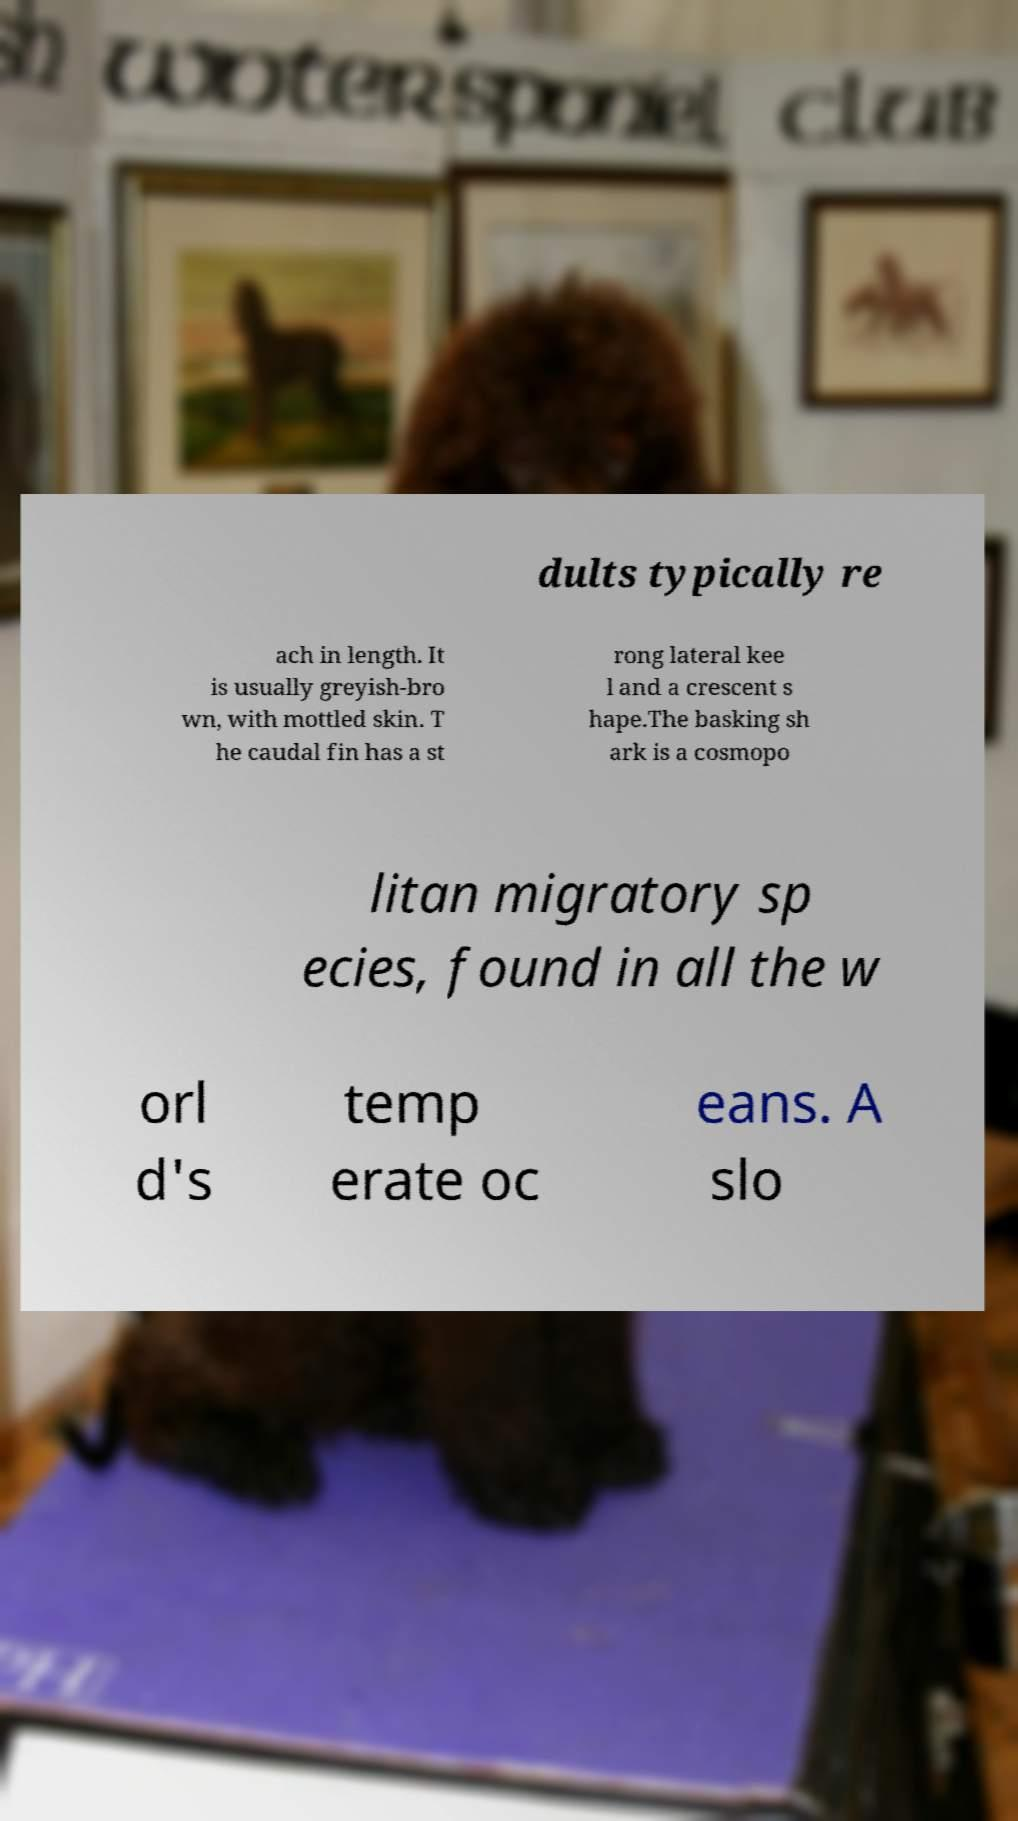Can you accurately transcribe the text from the provided image for me? dults typically re ach in length. It is usually greyish-bro wn, with mottled skin. T he caudal fin has a st rong lateral kee l and a crescent s hape.The basking sh ark is a cosmopo litan migratory sp ecies, found in all the w orl d's temp erate oc eans. A slo 